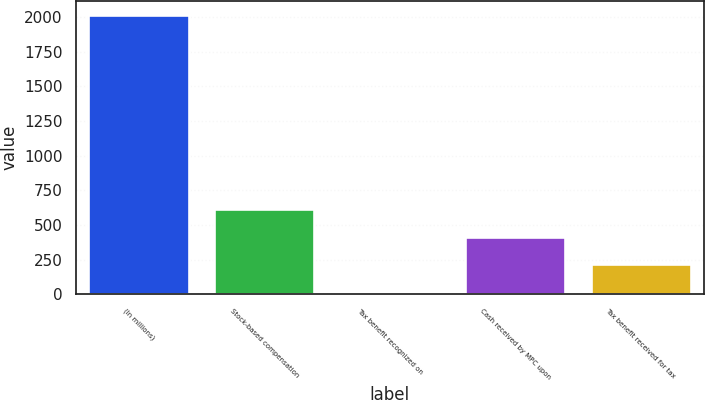Convert chart to OTSL. <chart><loc_0><loc_0><loc_500><loc_500><bar_chart><fcel>(In millions)<fcel>Stock-based compensation<fcel>Tax benefit recognized on<fcel>Cash received by MPC upon<fcel>Tax benefit received for tax<nl><fcel>2015<fcel>615.7<fcel>16<fcel>415.8<fcel>215.9<nl></chart> 